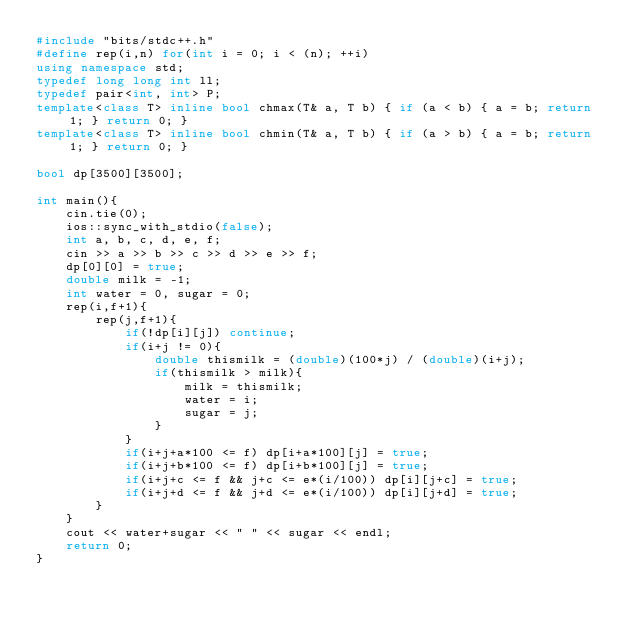Convert code to text. <code><loc_0><loc_0><loc_500><loc_500><_C++_>#include "bits/stdc++.h"
#define rep(i,n) for(int i = 0; i < (n); ++i)
using namespace std;
typedef long long int ll;
typedef pair<int, int> P;
template<class T> inline bool chmax(T& a, T b) { if (a < b) { a = b; return 1; } return 0; }
template<class T> inline bool chmin(T& a, T b) { if (a > b) { a = b; return 1; } return 0; }

bool dp[3500][3500];

int main(){
	cin.tie(0);
	ios::sync_with_stdio(false);
	int a, b, c, d, e, f;
	cin >> a >> b >> c >> d >> e >> f;
	dp[0][0] = true;
	double milk = -1;
	int water = 0, sugar = 0;
	rep(i,f+1){
		rep(j,f+1){
			if(!dp[i][j]) continue;
			if(i+j != 0){
				double thismilk = (double)(100*j) / (double)(i+j);
				if(thismilk > milk){
					milk = thismilk;
					water = i;
					sugar = j;
				}
			}
			if(i+j+a*100 <= f) dp[i+a*100][j] = true;
			if(i+j+b*100 <= f) dp[i+b*100][j] = true;
			if(i+j+c <= f && j+c <= e*(i/100)) dp[i][j+c] = true;
			if(i+j+d <= f && j+d <= e*(i/100)) dp[i][j+d] = true;
		}
	}
	cout << water+sugar << " " << sugar << endl;
	return 0;
}
</code> 